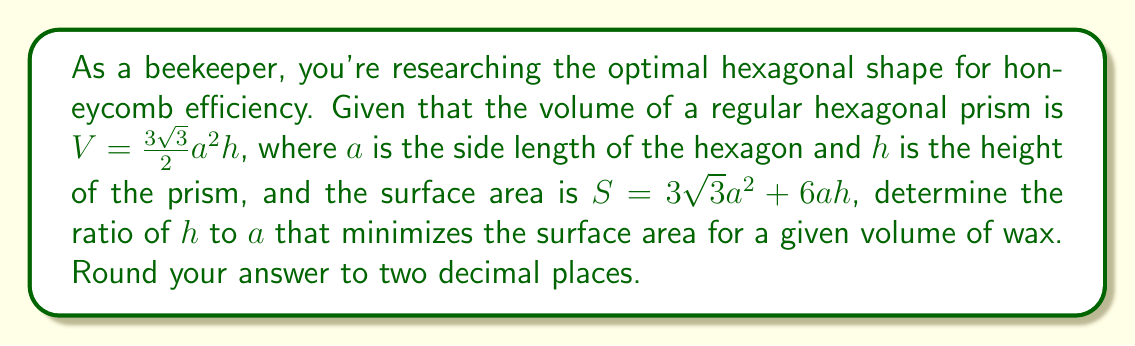Can you solve this math problem? To find the optimal ratio of $h$ to $a$, we'll use the method of Lagrange multipliers:

1) Let's define $r = \frac{h}{a}$. We want to express $S$ in terms of $a$ and $r$:

   $S = 3\sqrt{3}a^2 + 6a^2r$

2) The volume constraint can be written as:

   $V = \frac{3\sqrt{3}}{2}a^3r$

3) We introduce a Lagrange multiplier $\lambda$ and form the Lagrangian:

   $L = S - \lambda(V - k)$, where $k$ is a constant volume

4) We differentiate $L$ with respect to $a$, $r$, and $\lambda$:

   $\frac{\partial L}{\partial a} = 6\sqrt{3}a + 12ar - 3\sqrt{3}\lambda a^2r = 0$
   $\frac{\partial L}{\partial r} = 6a^2 - \frac{3\sqrt{3}}{2}\lambda a^3 = 0$
   $\frac{\partial L}{\partial \lambda} = \frac{3\sqrt{3}}{2}a^3r - k = 0$

5) From the second equation:

   $\lambda = \frac{4}{\sqrt{3}a}$

6) Substituting this into the first equation:

   $6\sqrt{3}a + 12ar - 4a^2r = 0$

7) Simplifying:

   $3\sqrt{3} + 6r - 2ar = 0$

8) Solving for $r$:

   $r = \frac{3\sqrt{3}}{2a - 6} = \frac{\sqrt{3}}{2 - \frac{2}{\sqrt{3}}r}$

9) This implies:

   $r^2 - \frac{2}{\sqrt{3}}r - \frac{1}{2} = 0$

10) Solving this quadratic equation:

    $r = \frac{1}{\sqrt{3}} + \sqrt{\frac{1}{3} + \frac{1}{2}} = \frac{1}{\sqrt{3}} + \frac{\sqrt{5}}{2\sqrt{3}} \approx 1.41$

Therefore, the optimal ratio of $h$ to $a$ is approximately 1.41.
Answer: 1.41 